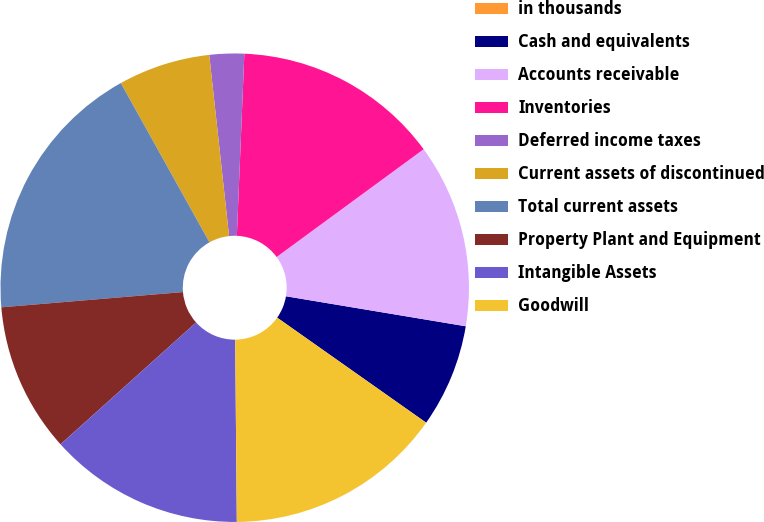Convert chart to OTSL. <chart><loc_0><loc_0><loc_500><loc_500><pie_chart><fcel>in thousands<fcel>Cash and equivalents<fcel>Accounts receivable<fcel>Inventories<fcel>Deferred income taxes<fcel>Current assets of discontinued<fcel>Total current assets<fcel>Property Plant and Equipment<fcel>Intangible Assets<fcel>Goodwill<nl><fcel>0.01%<fcel>7.14%<fcel>12.7%<fcel>14.28%<fcel>2.39%<fcel>6.35%<fcel>18.25%<fcel>10.32%<fcel>13.49%<fcel>15.08%<nl></chart> 